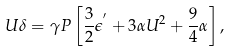Convert formula to latex. <formula><loc_0><loc_0><loc_500><loc_500>U \delta = \gamma P \left [ \frac { 3 } { 2 } \epsilon ^ { ^ { \prime } } + 3 \alpha U ^ { 2 } + \frac { 9 } { 4 } \alpha \right ] ,</formula> 